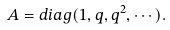<formula> <loc_0><loc_0><loc_500><loc_500>& \ A = d i a g ( 1 , q , q ^ { 2 } , \cdots ) .</formula> 